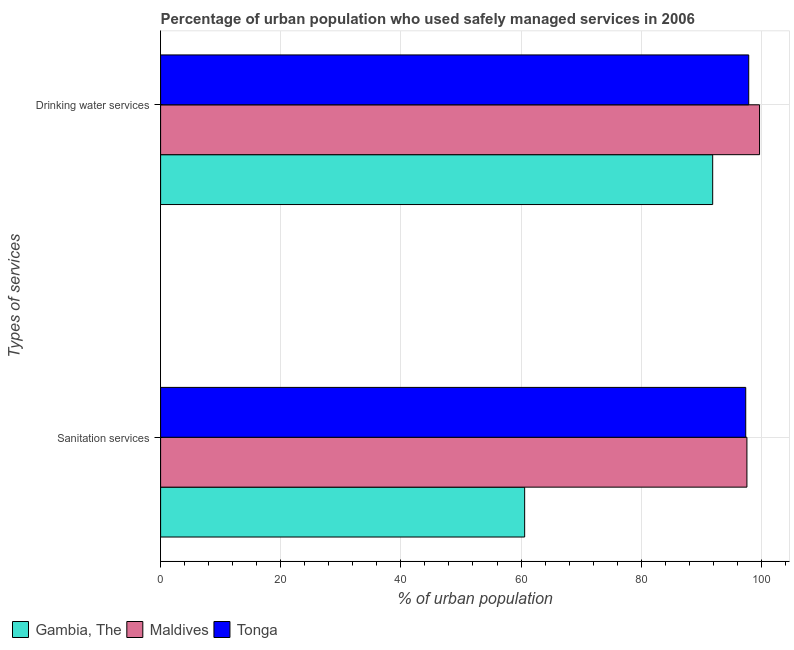How many groups of bars are there?
Keep it short and to the point. 2. How many bars are there on the 2nd tick from the bottom?
Provide a short and direct response. 3. What is the label of the 1st group of bars from the top?
Offer a very short reply. Drinking water services. What is the percentage of urban population who used drinking water services in Maldives?
Ensure brevity in your answer.  99.7. Across all countries, what is the maximum percentage of urban population who used drinking water services?
Your answer should be compact. 99.7. Across all countries, what is the minimum percentage of urban population who used drinking water services?
Provide a short and direct response. 91.9. In which country was the percentage of urban population who used sanitation services maximum?
Make the answer very short. Maldives. In which country was the percentage of urban population who used sanitation services minimum?
Provide a short and direct response. Gambia, The. What is the total percentage of urban population who used sanitation services in the graph?
Your response must be concise. 255.6. What is the difference between the percentage of urban population who used sanitation services in Maldives and that in Gambia, The?
Offer a terse response. 37. What is the difference between the percentage of urban population who used sanitation services in Tonga and the percentage of urban population who used drinking water services in Maldives?
Offer a terse response. -2.3. What is the average percentage of urban population who used sanitation services per country?
Provide a short and direct response. 85.2. What is the ratio of the percentage of urban population who used drinking water services in Tonga to that in Maldives?
Your answer should be very brief. 0.98. Is the percentage of urban population who used sanitation services in Gambia, The less than that in Maldives?
Provide a succinct answer. Yes. In how many countries, is the percentage of urban population who used drinking water services greater than the average percentage of urban population who used drinking water services taken over all countries?
Provide a succinct answer. 2. What does the 3rd bar from the top in Sanitation services represents?
Offer a very short reply. Gambia, The. What does the 3rd bar from the bottom in Drinking water services represents?
Offer a terse response. Tonga. Are all the bars in the graph horizontal?
Your response must be concise. Yes. Where does the legend appear in the graph?
Make the answer very short. Bottom left. How are the legend labels stacked?
Provide a short and direct response. Horizontal. What is the title of the graph?
Offer a very short reply. Percentage of urban population who used safely managed services in 2006. What is the label or title of the X-axis?
Keep it short and to the point. % of urban population. What is the label or title of the Y-axis?
Provide a short and direct response. Types of services. What is the % of urban population in Gambia, The in Sanitation services?
Give a very brief answer. 60.6. What is the % of urban population of Maldives in Sanitation services?
Ensure brevity in your answer.  97.6. What is the % of urban population in Tonga in Sanitation services?
Your response must be concise. 97.4. What is the % of urban population in Gambia, The in Drinking water services?
Keep it short and to the point. 91.9. What is the % of urban population of Maldives in Drinking water services?
Give a very brief answer. 99.7. What is the % of urban population of Tonga in Drinking water services?
Ensure brevity in your answer.  97.9. Across all Types of services, what is the maximum % of urban population in Gambia, The?
Offer a very short reply. 91.9. Across all Types of services, what is the maximum % of urban population of Maldives?
Ensure brevity in your answer.  99.7. Across all Types of services, what is the maximum % of urban population in Tonga?
Give a very brief answer. 97.9. Across all Types of services, what is the minimum % of urban population in Gambia, The?
Make the answer very short. 60.6. Across all Types of services, what is the minimum % of urban population of Maldives?
Your response must be concise. 97.6. Across all Types of services, what is the minimum % of urban population in Tonga?
Your answer should be compact. 97.4. What is the total % of urban population in Gambia, The in the graph?
Give a very brief answer. 152.5. What is the total % of urban population of Maldives in the graph?
Your response must be concise. 197.3. What is the total % of urban population in Tonga in the graph?
Keep it short and to the point. 195.3. What is the difference between the % of urban population in Gambia, The in Sanitation services and that in Drinking water services?
Provide a short and direct response. -31.3. What is the difference between the % of urban population of Maldives in Sanitation services and that in Drinking water services?
Ensure brevity in your answer.  -2.1. What is the difference between the % of urban population in Tonga in Sanitation services and that in Drinking water services?
Ensure brevity in your answer.  -0.5. What is the difference between the % of urban population in Gambia, The in Sanitation services and the % of urban population in Maldives in Drinking water services?
Give a very brief answer. -39.1. What is the difference between the % of urban population of Gambia, The in Sanitation services and the % of urban population of Tonga in Drinking water services?
Offer a terse response. -37.3. What is the average % of urban population of Gambia, The per Types of services?
Your answer should be very brief. 76.25. What is the average % of urban population in Maldives per Types of services?
Offer a terse response. 98.65. What is the average % of urban population in Tonga per Types of services?
Offer a very short reply. 97.65. What is the difference between the % of urban population of Gambia, The and % of urban population of Maldives in Sanitation services?
Your answer should be compact. -37. What is the difference between the % of urban population in Gambia, The and % of urban population in Tonga in Sanitation services?
Ensure brevity in your answer.  -36.8. What is the difference between the % of urban population in Maldives and % of urban population in Tonga in Drinking water services?
Offer a terse response. 1.8. What is the ratio of the % of urban population of Gambia, The in Sanitation services to that in Drinking water services?
Offer a terse response. 0.66. What is the ratio of the % of urban population in Maldives in Sanitation services to that in Drinking water services?
Your answer should be compact. 0.98. What is the difference between the highest and the second highest % of urban population of Gambia, The?
Offer a terse response. 31.3. What is the difference between the highest and the second highest % of urban population of Tonga?
Your response must be concise. 0.5. What is the difference between the highest and the lowest % of urban population in Gambia, The?
Offer a terse response. 31.3. What is the difference between the highest and the lowest % of urban population of Maldives?
Your response must be concise. 2.1. What is the difference between the highest and the lowest % of urban population in Tonga?
Give a very brief answer. 0.5. 